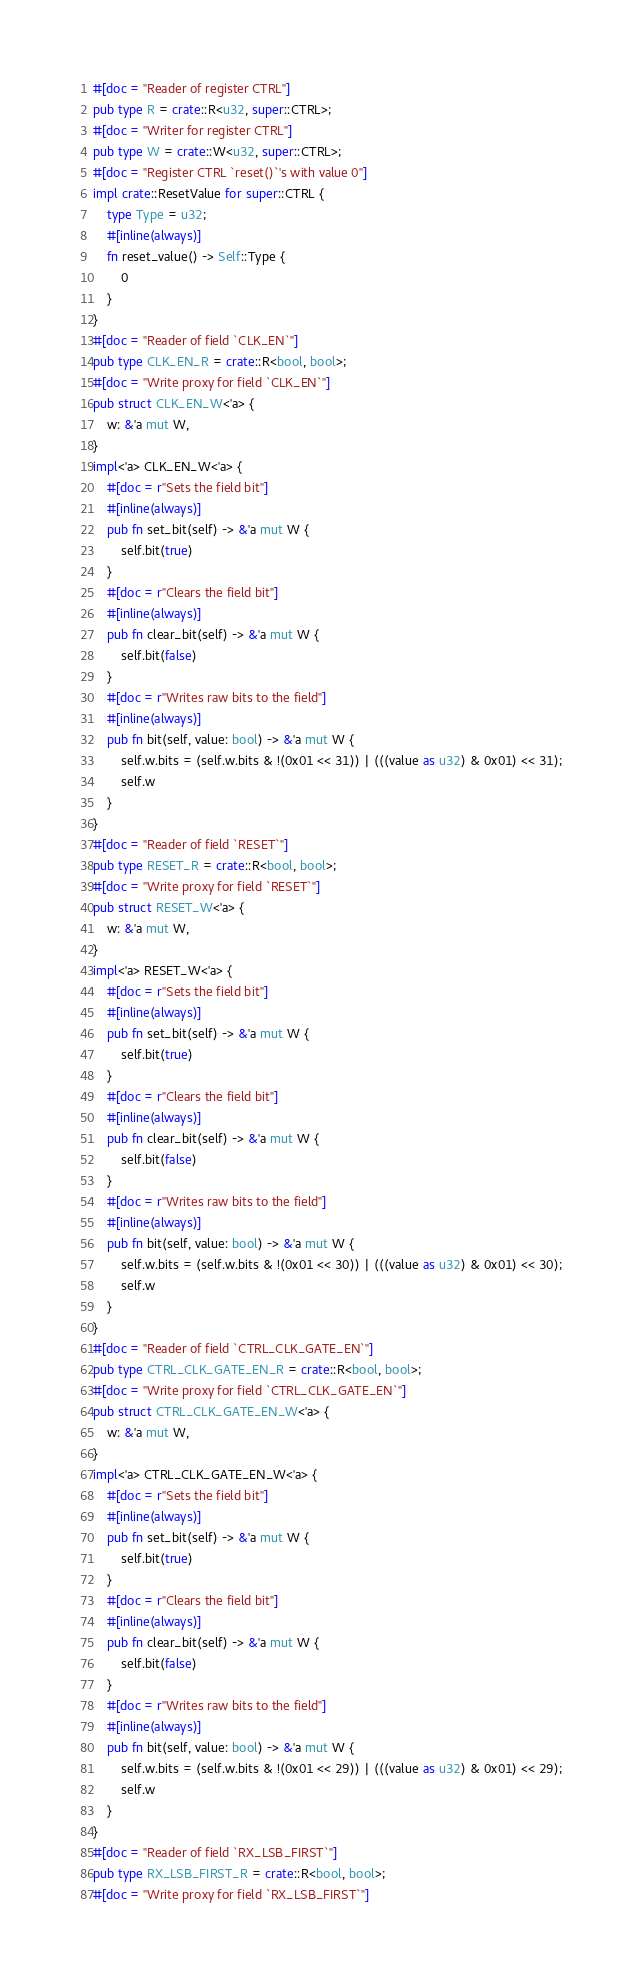Convert code to text. <code><loc_0><loc_0><loc_500><loc_500><_Rust_>#[doc = "Reader of register CTRL"]
pub type R = crate::R<u32, super::CTRL>;
#[doc = "Writer for register CTRL"]
pub type W = crate::W<u32, super::CTRL>;
#[doc = "Register CTRL `reset()`'s with value 0"]
impl crate::ResetValue for super::CTRL {
    type Type = u32;
    #[inline(always)]
    fn reset_value() -> Self::Type {
        0
    }
}
#[doc = "Reader of field `CLK_EN`"]
pub type CLK_EN_R = crate::R<bool, bool>;
#[doc = "Write proxy for field `CLK_EN`"]
pub struct CLK_EN_W<'a> {
    w: &'a mut W,
}
impl<'a> CLK_EN_W<'a> {
    #[doc = r"Sets the field bit"]
    #[inline(always)]
    pub fn set_bit(self) -> &'a mut W {
        self.bit(true)
    }
    #[doc = r"Clears the field bit"]
    #[inline(always)]
    pub fn clear_bit(self) -> &'a mut W {
        self.bit(false)
    }
    #[doc = r"Writes raw bits to the field"]
    #[inline(always)]
    pub fn bit(self, value: bool) -> &'a mut W {
        self.w.bits = (self.w.bits & !(0x01 << 31)) | (((value as u32) & 0x01) << 31);
        self.w
    }
}
#[doc = "Reader of field `RESET`"]
pub type RESET_R = crate::R<bool, bool>;
#[doc = "Write proxy for field `RESET`"]
pub struct RESET_W<'a> {
    w: &'a mut W,
}
impl<'a> RESET_W<'a> {
    #[doc = r"Sets the field bit"]
    #[inline(always)]
    pub fn set_bit(self) -> &'a mut W {
        self.bit(true)
    }
    #[doc = r"Clears the field bit"]
    #[inline(always)]
    pub fn clear_bit(self) -> &'a mut W {
        self.bit(false)
    }
    #[doc = r"Writes raw bits to the field"]
    #[inline(always)]
    pub fn bit(self, value: bool) -> &'a mut W {
        self.w.bits = (self.w.bits & !(0x01 << 30)) | (((value as u32) & 0x01) << 30);
        self.w
    }
}
#[doc = "Reader of field `CTRL_CLK_GATE_EN`"]
pub type CTRL_CLK_GATE_EN_R = crate::R<bool, bool>;
#[doc = "Write proxy for field `CTRL_CLK_GATE_EN`"]
pub struct CTRL_CLK_GATE_EN_W<'a> {
    w: &'a mut W,
}
impl<'a> CTRL_CLK_GATE_EN_W<'a> {
    #[doc = r"Sets the field bit"]
    #[inline(always)]
    pub fn set_bit(self) -> &'a mut W {
        self.bit(true)
    }
    #[doc = r"Clears the field bit"]
    #[inline(always)]
    pub fn clear_bit(self) -> &'a mut W {
        self.bit(false)
    }
    #[doc = r"Writes raw bits to the field"]
    #[inline(always)]
    pub fn bit(self, value: bool) -> &'a mut W {
        self.w.bits = (self.w.bits & !(0x01 << 29)) | (((value as u32) & 0x01) << 29);
        self.w
    }
}
#[doc = "Reader of field `RX_LSB_FIRST`"]
pub type RX_LSB_FIRST_R = crate::R<bool, bool>;
#[doc = "Write proxy for field `RX_LSB_FIRST`"]</code> 